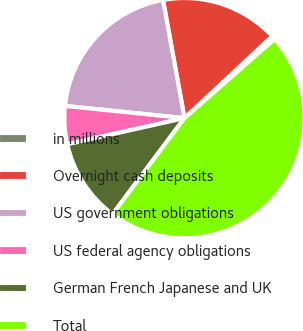<chart> <loc_0><loc_0><loc_500><loc_500><pie_chart><fcel>in millions<fcel>Overnight cash deposits<fcel>US government obligations<fcel>US federal agency obligations<fcel>German French Japanese and UK<fcel>Total<nl><fcel>0.5%<fcel>15.9%<fcel>20.52%<fcel>5.12%<fcel>11.28%<fcel>46.68%<nl></chart> 